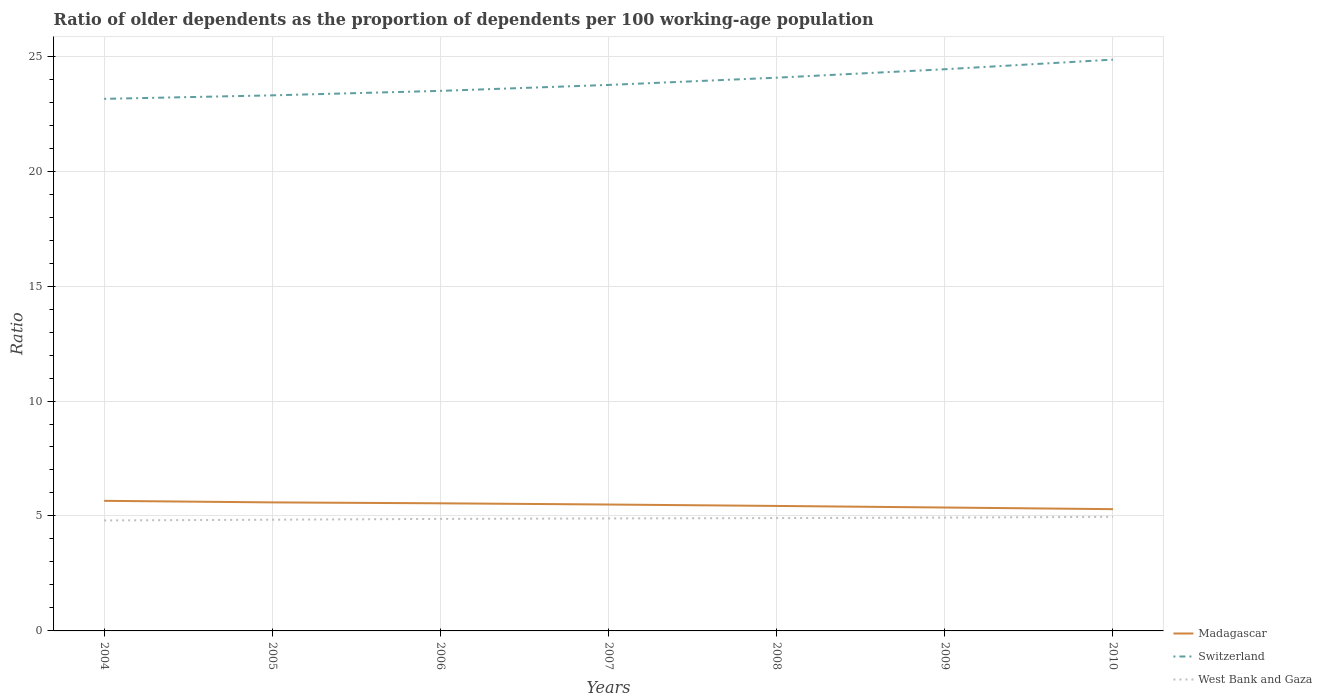Is the number of lines equal to the number of legend labels?
Offer a terse response. Yes. Across all years, what is the maximum age dependency ratio(old) in West Bank and Gaza?
Offer a very short reply. 4.81. In which year was the age dependency ratio(old) in West Bank and Gaza maximum?
Keep it short and to the point. 2004. What is the total age dependency ratio(old) in Switzerland in the graph?
Give a very brief answer. -0.37. What is the difference between the highest and the second highest age dependency ratio(old) in Madagascar?
Your answer should be very brief. 0.36. Is the age dependency ratio(old) in Madagascar strictly greater than the age dependency ratio(old) in Switzerland over the years?
Give a very brief answer. Yes. How many years are there in the graph?
Offer a terse response. 7. What is the difference between two consecutive major ticks on the Y-axis?
Make the answer very short. 5. Where does the legend appear in the graph?
Offer a very short reply. Bottom right. How are the legend labels stacked?
Give a very brief answer. Vertical. What is the title of the graph?
Give a very brief answer. Ratio of older dependents as the proportion of dependents per 100 working-age population. Does "Andorra" appear as one of the legend labels in the graph?
Offer a terse response. No. What is the label or title of the Y-axis?
Your answer should be compact. Ratio. What is the Ratio in Madagascar in 2004?
Keep it short and to the point. 5.66. What is the Ratio of Switzerland in 2004?
Keep it short and to the point. 23.14. What is the Ratio in West Bank and Gaza in 2004?
Provide a succinct answer. 4.81. What is the Ratio of Madagascar in 2005?
Your answer should be compact. 5.59. What is the Ratio of Switzerland in 2005?
Make the answer very short. 23.3. What is the Ratio of West Bank and Gaza in 2005?
Keep it short and to the point. 4.84. What is the Ratio of Madagascar in 2006?
Keep it short and to the point. 5.55. What is the Ratio in Switzerland in 2006?
Your answer should be very brief. 23.49. What is the Ratio in West Bank and Gaza in 2006?
Provide a short and direct response. 4.87. What is the Ratio of Madagascar in 2007?
Your response must be concise. 5.5. What is the Ratio in Switzerland in 2007?
Offer a very short reply. 23.75. What is the Ratio in West Bank and Gaza in 2007?
Keep it short and to the point. 4.89. What is the Ratio in Madagascar in 2008?
Provide a short and direct response. 5.44. What is the Ratio of Switzerland in 2008?
Offer a terse response. 24.06. What is the Ratio in West Bank and Gaza in 2008?
Keep it short and to the point. 4.91. What is the Ratio of Madagascar in 2009?
Your answer should be very brief. 5.37. What is the Ratio of Switzerland in 2009?
Offer a very short reply. 24.43. What is the Ratio in West Bank and Gaza in 2009?
Your response must be concise. 4.93. What is the Ratio of Madagascar in 2010?
Offer a very short reply. 5.3. What is the Ratio of Switzerland in 2010?
Your answer should be very brief. 24.85. What is the Ratio of West Bank and Gaza in 2010?
Give a very brief answer. 4.96. Across all years, what is the maximum Ratio in Madagascar?
Your answer should be compact. 5.66. Across all years, what is the maximum Ratio of Switzerland?
Your answer should be compact. 24.85. Across all years, what is the maximum Ratio in West Bank and Gaza?
Make the answer very short. 4.96. Across all years, what is the minimum Ratio in Madagascar?
Your answer should be compact. 5.3. Across all years, what is the minimum Ratio in Switzerland?
Give a very brief answer. 23.14. Across all years, what is the minimum Ratio of West Bank and Gaza?
Offer a terse response. 4.81. What is the total Ratio in Madagascar in the graph?
Your response must be concise. 38.4. What is the total Ratio of Switzerland in the graph?
Provide a short and direct response. 167.02. What is the total Ratio of West Bank and Gaza in the graph?
Make the answer very short. 34.21. What is the difference between the Ratio of Madagascar in 2004 and that in 2005?
Provide a short and direct response. 0.07. What is the difference between the Ratio in Switzerland in 2004 and that in 2005?
Keep it short and to the point. -0.15. What is the difference between the Ratio in West Bank and Gaza in 2004 and that in 2005?
Offer a terse response. -0.03. What is the difference between the Ratio of Madagascar in 2004 and that in 2006?
Offer a very short reply. 0.11. What is the difference between the Ratio of Switzerland in 2004 and that in 2006?
Keep it short and to the point. -0.35. What is the difference between the Ratio of West Bank and Gaza in 2004 and that in 2006?
Your answer should be compact. -0.07. What is the difference between the Ratio in Madagascar in 2004 and that in 2007?
Your answer should be very brief. 0.16. What is the difference between the Ratio in Switzerland in 2004 and that in 2007?
Offer a very short reply. -0.61. What is the difference between the Ratio in West Bank and Gaza in 2004 and that in 2007?
Offer a terse response. -0.09. What is the difference between the Ratio of Madagascar in 2004 and that in 2008?
Your answer should be very brief. 0.22. What is the difference between the Ratio of Switzerland in 2004 and that in 2008?
Provide a short and direct response. -0.92. What is the difference between the Ratio of West Bank and Gaza in 2004 and that in 2008?
Keep it short and to the point. -0.1. What is the difference between the Ratio in Madagascar in 2004 and that in 2009?
Provide a short and direct response. 0.29. What is the difference between the Ratio in Switzerland in 2004 and that in 2009?
Offer a very short reply. -1.29. What is the difference between the Ratio of West Bank and Gaza in 2004 and that in 2009?
Keep it short and to the point. -0.12. What is the difference between the Ratio of Madagascar in 2004 and that in 2010?
Offer a terse response. 0.36. What is the difference between the Ratio of Switzerland in 2004 and that in 2010?
Your answer should be compact. -1.71. What is the difference between the Ratio in West Bank and Gaza in 2004 and that in 2010?
Make the answer very short. -0.16. What is the difference between the Ratio in Madagascar in 2005 and that in 2006?
Give a very brief answer. 0.04. What is the difference between the Ratio in Switzerland in 2005 and that in 2006?
Provide a succinct answer. -0.19. What is the difference between the Ratio in West Bank and Gaza in 2005 and that in 2006?
Give a very brief answer. -0.04. What is the difference between the Ratio in Madagascar in 2005 and that in 2007?
Offer a very short reply. 0.09. What is the difference between the Ratio of Switzerland in 2005 and that in 2007?
Give a very brief answer. -0.45. What is the difference between the Ratio in West Bank and Gaza in 2005 and that in 2007?
Make the answer very short. -0.06. What is the difference between the Ratio of Madagascar in 2005 and that in 2008?
Provide a succinct answer. 0.15. What is the difference between the Ratio of Switzerland in 2005 and that in 2008?
Ensure brevity in your answer.  -0.77. What is the difference between the Ratio of West Bank and Gaza in 2005 and that in 2008?
Your response must be concise. -0.07. What is the difference between the Ratio in Madagascar in 2005 and that in 2009?
Your response must be concise. 0.22. What is the difference between the Ratio in Switzerland in 2005 and that in 2009?
Your answer should be compact. -1.14. What is the difference between the Ratio in West Bank and Gaza in 2005 and that in 2009?
Ensure brevity in your answer.  -0.09. What is the difference between the Ratio in Madagascar in 2005 and that in 2010?
Ensure brevity in your answer.  0.29. What is the difference between the Ratio of Switzerland in 2005 and that in 2010?
Keep it short and to the point. -1.55. What is the difference between the Ratio of West Bank and Gaza in 2005 and that in 2010?
Give a very brief answer. -0.12. What is the difference between the Ratio of Madagascar in 2006 and that in 2007?
Offer a very short reply. 0.05. What is the difference between the Ratio of Switzerland in 2006 and that in 2007?
Keep it short and to the point. -0.26. What is the difference between the Ratio in West Bank and Gaza in 2006 and that in 2007?
Your answer should be very brief. -0.02. What is the difference between the Ratio of Madagascar in 2006 and that in 2008?
Keep it short and to the point. 0.11. What is the difference between the Ratio in Switzerland in 2006 and that in 2008?
Ensure brevity in your answer.  -0.57. What is the difference between the Ratio of West Bank and Gaza in 2006 and that in 2008?
Provide a succinct answer. -0.04. What is the difference between the Ratio in Madagascar in 2006 and that in 2009?
Your answer should be very brief. 0.18. What is the difference between the Ratio in Switzerland in 2006 and that in 2009?
Your response must be concise. -0.94. What is the difference between the Ratio of West Bank and Gaza in 2006 and that in 2009?
Keep it short and to the point. -0.06. What is the difference between the Ratio in Madagascar in 2006 and that in 2010?
Offer a terse response. 0.25. What is the difference between the Ratio in Switzerland in 2006 and that in 2010?
Your answer should be compact. -1.36. What is the difference between the Ratio of West Bank and Gaza in 2006 and that in 2010?
Your answer should be compact. -0.09. What is the difference between the Ratio of Madagascar in 2007 and that in 2008?
Your answer should be very brief. 0.06. What is the difference between the Ratio of Switzerland in 2007 and that in 2008?
Offer a very short reply. -0.32. What is the difference between the Ratio of West Bank and Gaza in 2007 and that in 2008?
Keep it short and to the point. -0.01. What is the difference between the Ratio of Madagascar in 2007 and that in 2009?
Your answer should be very brief. 0.13. What is the difference between the Ratio in Switzerland in 2007 and that in 2009?
Provide a short and direct response. -0.68. What is the difference between the Ratio in West Bank and Gaza in 2007 and that in 2009?
Your response must be concise. -0.04. What is the difference between the Ratio of Madagascar in 2007 and that in 2010?
Provide a short and direct response. 0.2. What is the difference between the Ratio of Switzerland in 2007 and that in 2010?
Offer a terse response. -1.1. What is the difference between the Ratio in West Bank and Gaza in 2007 and that in 2010?
Provide a succinct answer. -0.07. What is the difference between the Ratio of Madagascar in 2008 and that in 2009?
Offer a very short reply. 0.07. What is the difference between the Ratio of Switzerland in 2008 and that in 2009?
Your response must be concise. -0.37. What is the difference between the Ratio of West Bank and Gaza in 2008 and that in 2009?
Your response must be concise. -0.02. What is the difference between the Ratio of Madagascar in 2008 and that in 2010?
Keep it short and to the point. 0.14. What is the difference between the Ratio in Switzerland in 2008 and that in 2010?
Give a very brief answer. -0.79. What is the difference between the Ratio in West Bank and Gaza in 2008 and that in 2010?
Provide a short and direct response. -0.05. What is the difference between the Ratio in Madagascar in 2009 and that in 2010?
Give a very brief answer. 0.07. What is the difference between the Ratio in Switzerland in 2009 and that in 2010?
Provide a short and direct response. -0.42. What is the difference between the Ratio in West Bank and Gaza in 2009 and that in 2010?
Make the answer very short. -0.03. What is the difference between the Ratio of Madagascar in 2004 and the Ratio of Switzerland in 2005?
Your answer should be compact. -17.64. What is the difference between the Ratio in Madagascar in 2004 and the Ratio in West Bank and Gaza in 2005?
Your answer should be very brief. 0.82. What is the difference between the Ratio of Switzerland in 2004 and the Ratio of West Bank and Gaza in 2005?
Provide a succinct answer. 18.31. What is the difference between the Ratio in Madagascar in 2004 and the Ratio in Switzerland in 2006?
Your answer should be compact. -17.83. What is the difference between the Ratio in Madagascar in 2004 and the Ratio in West Bank and Gaza in 2006?
Provide a succinct answer. 0.79. What is the difference between the Ratio of Switzerland in 2004 and the Ratio of West Bank and Gaza in 2006?
Offer a very short reply. 18.27. What is the difference between the Ratio in Madagascar in 2004 and the Ratio in Switzerland in 2007?
Provide a succinct answer. -18.09. What is the difference between the Ratio in Madagascar in 2004 and the Ratio in West Bank and Gaza in 2007?
Offer a very short reply. 0.77. What is the difference between the Ratio in Switzerland in 2004 and the Ratio in West Bank and Gaza in 2007?
Make the answer very short. 18.25. What is the difference between the Ratio of Madagascar in 2004 and the Ratio of Switzerland in 2008?
Your answer should be compact. -18.41. What is the difference between the Ratio of Madagascar in 2004 and the Ratio of West Bank and Gaza in 2008?
Give a very brief answer. 0.75. What is the difference between the Ratio of Switzerland in 2004 and the Ratio of West Bank and Gaza in 2008?
Give a very brief answer. 18.24. What is the difference between the Ratio of Madagascar in 2004 and the Ratio of Switzerland in 2009?
Make the answer very short. -18.77. What is the difference between the Ratio in Madagascar in 2004 and the Ratio in West Bank and Gaza in 2009?
Your answer should be very brief. 0.73. What is the difference between the Ratio in Switzerland in 2004 and the Ratio in West Bank and Gaza in 2009?
Provide a short and direct response. 18.21. What is the difference between the Ratio in Madagascar in 2004 and the Ratio in Switzerland in 2010?
Your response must be concise. -19.19. What is the difference between the Ratio in Madagascar in 2004 and the Ratio in West Bank and Gaza in 2010?
Offer a very short reply. 0.7. What is the difference between the Ratio in Switzerland in 2004 and the Ratio in West Bank and Gaza in 2010?
Your answer should be very brief. 18.18. What is the difference between the Ratio in Madagascar in 2005 and the Ratio in Switzerland in 2006?
Give a very brief answer. -17.9. What is the difference between the Ratio of Madagascar in 2005 and the Ratio of West Bank and Gaza in 2006?
Ensure brevity in your answer.  0.72. What is the difference between the Ratio in Switzerland in 2005 and the Ratio in West Bank and Gaza in 2006?
Give a very brief answer. 18.42. What is the difference between the Ratio of Madagascar in 2005 and the Ratio of Switzerland in 2007?
Keep it short and to the point. -18.16. What is the difference between the Ratio in Madagascar in 2005 and the Ratio in West Bank and Gaza in 2007?
Your answer should be compact. 0.7. What is the difference between the Ratio of Switzerland in 2005 and the Ratio of West Bank and Gaza in 2007?
Provide a short and direct response. 18.4. What is the difference between the Ratio in Madagascar in 2005 and the Ratio in Switzerland in 2008?
Your answer should be compact. -18.47. What is the difference between the Ratio of Madagascar in 2005 and the Ratio of West Bank and Gaza in 2008?
Provide a short and direct response. 0.68. What is the difference between the Ratio in Switzerland in 2005 and the Ratio in West Bank and Gaza in 2008?
Keep it short and to the point. 18.39. What is the difference between the Ratio of Madagascar in 2005 and the Ratio of Switzerland in 2009?
Provide a succinct answer. -18.84. What is the difference between the Ratio of Madagascar in 2005 and the Ratio of West Bank and Gaza in 2009?
Offer a terse response. 0.66. What is the difference between the Ratio of Switzerland in 2005 and the Ratio of West Bank and Gaza in 2009?
Make the answer very short. 18.37. What is the difference between the Ratio of Madagascar in 2005 and the Ratio of Switzerland in 2010?
Provide a short and direct response. -19.26. What is the difference between the Ratio of Madagascar in 2005 and the Ratio of West Bank and Gaza in 2010?
Ensure brevity in your answer.  0.63. What is the difference between the Ratio of Switzerland in 2005 and the Ratio of West Bank and Gaza in 2010?
Make the answer very short. 18.33. What is the difference between the Ratio of Madagascar in 2006 and the Ratio of Switzerland in 2007?
Give a very brief answer. -18.2. What is the difference between the Ratio of Madagascar in 2006 and the Ratio of West Bank and Gaza in 2007?
Your answer should be compact. 0.66. What is the difference between the Ratio of Switzerland in 2006 and the Ratio of West Bank and Gaza in 2007?
Offer a terse response. 18.6. What is the difference between the Ratio in Madagascar in 2006 and the Ratio in Switzerland in 2008?
Your answer should be very brief. -18.51. What is the difference between the Ratio in Madagascar in 2006 and the Ratio in West Bank and Gaza in 2008?
Your response must be concise. 0.64. What is the difference between the Ratio in Switzerland in 2006 and the Ratio in West Bank and Gaza in 2008?
Your answer should be very brief. 18.58. What is the difference between the Ratio in Madagascar in 2006 and the Ratio in Switzerland in 2009?
Offer a very short reply. -18.88. What is the difference between the Ratio of Madagascar in 2006 and the Ratio of West Bank and Gaza in 2009?
Your answer should be compact. 0.62. What is the difference between the Ratio of Switzerland in 2006 and the Ratio of West Bank and Gaza in 2009?
Your answer should be compact. 18.56. What is the difference between the Ratio in Madagascar in 2006 and the Ratio in Switzerland in 2010?
Offer a very short reply. -19.3. What is the difference between the Ratio of Madagascar in 2006 and the Ratio of West Bank and Gaza in 2010?
Your response must be concise. 0.59. What is the difference between the Ratio in Switzerland in 2006 and the Ratio in West Bank and Gaza in 2010?
Keep it short and to the point. 18.53. What is the difference between the Ratio of Madagascar in 2007 and the Ratio of Switzerland in 2008?
Your answer should be compact. -18.57. What is the difference between the Ratio in Madagascar in 2007 and the Ratio in West Bank and Gaza in 2008?
Provide a succinct answer. 0.59. What is the difference between the Ratio in Switzerland in 2007 and the Ratio in West Bank and Gaza in 2008?
Ensure brevity in your answer.  18.84. What is the difference between the Ratio of Madagascar in 2007 and the Ratio of Switzerland in 2009?
Give a very brief answer. -18.93. What is the difference between the Ratio in Madagascar in 2007 and the Ratio in West Bank and Gaza in 2009?
Make the answer very short. 0.57. What is the difference between the Ratio in Switzerland in 2007 and the Ratio in West Bank and Gaza in 2009?
Give a very brief answer. 18.82. What is the difference between the Ratio in Madagascar in 2007 and the Ratio in Switzerland in 2010?
Give a very brief answer. -19.35. What is the difference between the Ratio of Madagascar in 2007 and the Ratio of West Bank and Gaza in 2010?
Give a very brief answer. 0.54. What is the difference between the Ratio in Switzerland in 2007 and the Ratio in West Bank and Gaza in 2010?
Offer a very short reply. 18.79. What is the difference between the Ratio in Madagascar in 2008 and the Ratio in Switzerland in 2009?
Keep it short and to the point. -18.99. What is the difference between the Ratio in Madagascar in 2008 and the Ratio in West Bank and Gaza in 2009?
Ensure brevity in your answer.  0.51. What is the difference between the Ratio of Switzerland in 2008 and the Ratio of West Bank and Gaza in 2009?
Keep it short and to the point. 19.13. What is the difference between the Ratio of Madagascar in 2008 and the Ratio of Switzerland in 2010?
Offer a very short reply. -19.41. What is the difference between the Ratio in Madagascar in 2008 and the Ratio in West Bank and Gaza in 2010?
Your response must be concise. 0.47. What is the difference between the Ratio in Switzerland in 2008 and the Ratio in West Bank and Gaza in 2010?
Make the answer very short. 19.1. What is the difference between the Ratio of Madagascar in 2009 and the Ratio of Switzerland in 2010?
Provide a short and direct response. -19.48. What is the difference between the Ratio in Madagascar in 2009 and the Ratio in West Bank and Gaza in 2010?
Ensure brevity in your answer.  0.41. What is the difference between the Ratio in Switzerland in 2009 and the Ratio in West Bank and Gaza in 2010?
Your response must be concise. 19.47. What is the average Ratio in Madagascar per year?
Provide a short and direct response. 5.49. What is the average Ratio in Switzerland per year?
Give a very brief answer. 23.86. What is the average Ratio in West Bank and Gaza per year?
Make the answer very short. 4.89. In the year 2004, what is the difference between the Ratio in Madagascar and Ratio in Switzerland?
Your answer should be compact. -17.48. In the year 2004, what is the difference between the Ratio of Madagascar and Ratio of West Bank and Gaza?
Keep it short and to the point. 0.85. In the year 2004, what is the difference between the Ratio of Switzerland and Ratio of West Bank and Gaza?
Offer a terse response. 18.34. In the year 2005, what is the difference between the Ratio in Madagascar and Ratio in Switzerland?
Offer a very short reply. -17.7. In the year 2005, what is the difference between the Ratio of Madagascar and Ratio of West Bank and Gaza?
Offer a terse response. 0.75. In the year 2005, what is the difference between the Ratio of Switzerland and Ratio of West Bank and Gaza?
Provide a succinct answer. 18.46. In the year 2006, what is the difference between the Ratio of Madagascar and Ratio of Switzerland?
Your response must be concise. -17.94. In the year 2006, what is the difference between the Ratio of Madagascar and Ratio of West Bank and Gaza?
Make the answer very short. 0.68. In the year 2006, what is the difference between the Ratio in Switzerland and Ratio in West Bank and Gaza?
Your response must be concise. 18.62. In the year 2007, what is the difference between the Ratio in Madagascar and Ratio in Switzerland?
Make the answer very short. -18.25. In the year 2007, what is the difference between the Ratio of Madagascar and Ratio of West Bank and Gaza?
Ensure brevity in your answer.  0.6. In the year 2007, what is the difference between the Ratio in Switzerland and Ratio in West Bank and Gaza?
Provide a short and direct response. 18.86. In the year 2008, what is the difference between the Ratio of Madagascar and Ratio of Switzerland?
Ensure brevity in your answer.  -18.63. In the year 2008, what is the difference between the Ratio of Madagascar and Ratio of West Bank and Gaza?
Your response must be concise. 0.53. In the year 2008, what is the difference between the Ratio of Switzerland and Ratio of West Bank and Gaza?
Offer a terse response. 19.16. In the year 2009, what is the difference between the Ratio in Madagascar and Ratio in Switzerland?
Make the answer very short. -19.06. In the year 2009, what is the difference between the Ratio in Madagascar and Ratio in West Bank and Gaza?
Offer a terse response. 0.44. In the year 2009, what is the difference between the Ratio of Switzerland and Ratio of West Bank and Gaza?
Make the answer very short. 19.5. In the year 2010, what is the difference between the Ratio in Madagascar and Ratio in Switzerland?
Ensure brevity in your answer.  -19.55. In the year 2010, what is the difference between the Ratio in Madagascar and Ratio in West Bank and Gaza?
Give a very brief answer. 0.33. In the year 2010, what is the difference between the Ratio of Switzerland and Ratio of West Bank and Gaza?
Offer a terse response. 19.89. What is the ratio of the Ratio of Madagascar in 2004 to that in 2005?
Provide a succinct answer. 1.01. What is the ratio of the Ratio in Madagascar in 2004 to that in 2006?
Provide a short and direct response. 1.02. What is the ratio of the Ratio in Switzerland in 2004 to that in 2006?
Keep it short and to the point. 0.99. What is the ratio of the Ratio of West Bank and Gaza in 2004 to that in 2006?
Your answer should be very brief. 0.99. What is the ratio of the Ratio of Madagascar in 2004 to that in 2007?
Keep it short and to the point. 1.03. What is the ratio of the Ratio of Switzerland in 2004 to that in 2007?
Provide a succinct answer. 0.97. What is the ratio of the Ratio of West Bank and Gaza in 2004 to that in 2007?
Offer a terse response. 0.98. What is the ratio of the Ratio in Madagascar in 2004 to that in 2008?
Give a very brief answer. 1.04. What is the ratio of the Ratio of Switzerland in 2004 to that in 2008?
Give a very brief answer. 0.96. What is the ratio of the Ratio in West Bank and Gaza in 2004 to that in 2008?
Give a very brief answer. 0.98. What is the ratio of the Ratio of Madagascar in 2004 to that in 2009?
Offer a terse response. 1.05. What is the ratio of the Ratio of Switzerland in 2004 to that in 2009?
Provide a short and direct response. 0.95. What is the ratio of the Ratio in West Bank and Gaza in 2004 to that in 2009?
Give a very brief answer. 0.97. What is the ratio of the Ratio of Madagascar in 2004 to that in 2010?
Your answer should be very brief. 1.07. What is the ratio of the Ratio of Switzerland in 2004 to that in 2010?
Your answer should be compact. 0.93. What is the ratio of the Ratio of West Bank and Gaza in 2004 to that in 2010?
Keep it short and to the point. 0.97. What is the ratio of the Ratio of Madagascar in 2005 to that in 2006?
Make the answer very short. 1.01. What is the ratio of the Ratio of West Bank and Gaza in 2005 to that in 2006?
Your answer should be compact. 0.99. What is the ratio of the Ratio of Madagascar in 2005 to that in 2007?
Give a very brief answer. 1.02. What is the ratio of the Ratio in Switzerland in 2005 to that in 2007?
Provide a succinct answer. 0.98. What is the ratio of the Ratio of West Bank and Gaza in 2005 to that in 2007?
Make the answer very short. 0.99. What is the ratio of the Ratio in Madagascar in 2005 to that in 2008?
Ensure brevity in your answer.  1.03. What is the ratio of the Ratio of Switzerland in 2005 to that in 2008?
Your answer should be very brief. 0.97. What is the ratio of the Ratio of West Bank and Gaza in 2005 to that in 2008?
Provide a succinct answer. 0.99. What is the ratio of the Ratio of Madagascar in 2005 to that in 2009?
Provide a succinct answer. 1.04. What is the ratio of the Ratio in Switzerland in 2005 to that in 2009?
Offer a terse response. 0.95. What is the ratio of the Ratio of West Bank and Gaza in 2005 to that in 2009?
Provide a short and direct response. 0.98. What is the ratio of the Ratio in Madagascar in 2005 to that in 2010?
Give a very brief answer. 1.06. What is the ratio of the Ratio in West Bank and Gaza in 2005 to that in 2010?
Your response must be concise. 0.97. What is the ratio of the Ratio of Madagascar in 2006 to that in 2007?
Offer a terse response. 1.01. What is the ratio of the Ratio of Madagascar in 2006 to that in 2008?
Offer a very short reply. 1.02. What is the ratio of the Ratio of Switzerland in 2006 to that in 2008?
Offer a terse response. 0.98. What is the ratio of the Ratio of Madagascar in 2006 to that in 2009?
Your response must be concise. 1.03. What is the ratio of the Ratio in Switzerland in 2006 to that in 2009?
Give a very brief answer. 0.96. What is the ratio of the Ratio of Madagascar in 2006 to that in 2010?
Provide a succinct answer. 1.05. What is the ratio of the Ratio in Switzerland in 2006 to that in 2010?
Your response must be concise. 0.95. What is the ratio of the Ratio in Madagascar in 2007 to that in 2008?
Make the answer very short. 1.01. What is the ratio of the Ratio of Switzerland in 2007 to that in 2008?
Provide a short and direct response. 0.99. What is the ratio of the Ratio in Madagascar in 2007 to that in 2009?
Your answer should be compact. 1.02. What is the ratio of the Ratio in Switzerland in 2007 to that in 2009?
Your response must be concise. 0.97. What is the ratio of the Ratio in West Bank and Gaza in 2007 to that in 2009?
Give a very brief answer. 0.99. What is the ratio of the Ratio in Madagascar in 2007 to that in 2010?
Your answer should be very brief. 1.04. What is the ratio of the Ratio of Switzerland in 2007 to that in 2010?
Ensure brevity in your answer.  0.96. What is the ratio of the Ratio of West Bank and Gaza in 2007 to that in 2010?
Your answer should be very brief. 0.99. What is the ratio of the Ratio of Madagascar in 2008 to that in 2009?
Your response must be concise. 1.01. What is the ratio of the Ratio of Switzerland in 2008 to that in 2009?
Give a very brief answer. 0.98. What is the ratio of the Ratio in Madagascar in 2008 to that in 2010?
Your answer should be compact. 1.03. What is the ratio of the Ratio in Switzerland in 2008 to that in 2010?
Offer a very short reply. 0.97. What is the ratio of the Ratio of West Bank and Gaza in 2008 to that in 2010?
Your answer should be compact. 0.99. What is the ratio of the Ratio in Madagascar in 2009 to that in 2010?
Your response must be concise. 1.01. What is the ratio of the Ratio of Switzerland in 2009 to that in 2010?
Make the answer very short. 0.98. What is the difference between the highest and the second highest Ratio of Madagascar?
Give a very brief answer. 0.07. What is the difference between the highest and the second highest Ratio in Switzerland?
Provide a short and direct response. 0.42. What is the difference between the highest and the second highest Ratio in West Bank and Gaza?
Offer a very short reply. 0.03. What is the difference between the highest and the lowest Ratio in Madagascar?
Provide a succinct answer. 0.36. What is the difference between the highest and the lowest Ratio of Switzerland?
Your answer should be very brief. 1.71. What is the difference between the highest and the lowest Ratio of West Bank and Gaza?
Provide a short and direct response. 0.16. 